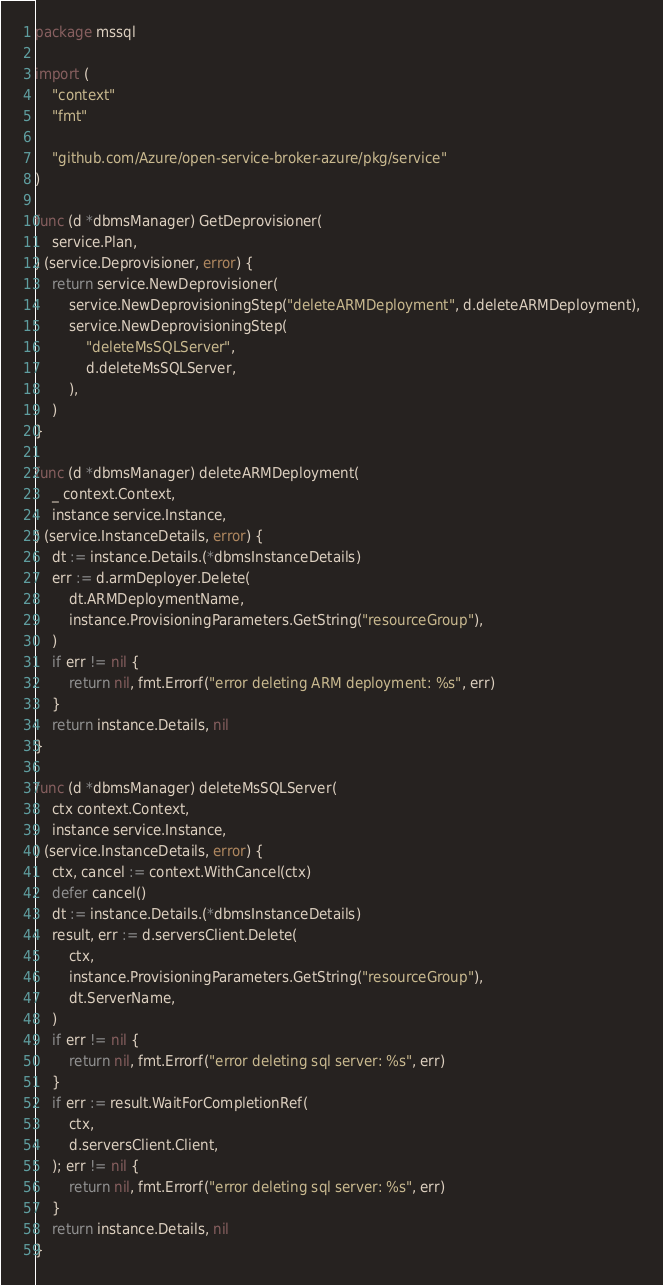Convert code to text. <code><loc_0><loc_0><loc_500><loc_500><_Go_>package mssql

import (
	"context"
	"fmt"

	"github.com/Azure/open-service-broker-azure/pkg/service"
)

func (d *dbmsManager) GetDeprovisioner(
	service.Plan,
) (service.Deprovisioner, error) {
	return service.NewDeprovisioner(
		service.NewDeprovisioningStep("deleteARMDeployment", d.deleteARMDeployment),
		service.NewDeprovisioningStep(
			"deleteMsSQLServer",
			d.deleteMsSQLServer,
		),
	)
}

func (d *dbmsManager) deleteARMDeployment(
	_ context.Context,
	instance service.Instance,
) (service.InstanceDetails, error) {
	dt := instance.Details.(*dbmsInstanceDetails)
	err := d.armDeployer.Delete(
		dt.ARMDeploymentName,
		instance.ProvisioningParameters.GetString("resourceGroup"),
	)
	if err != nil {
		return nil, fmt.Errorf("error deleting ARM deployment: %s", err)
	}
	return instance.Details, nil
}

func (d *dbmsManager) deleteMsSQLServer(
	ctx context.Context,
	instance service.Instance,
) (service.InstanceDetails, error) {
	ctx, cancel := context.WithCancel(ctx)
	defer cancel()
	dt := instance.Details.(*dbmsInstanceDetails)
	result, err := d.serversClient.Delete(
		ctx,
		instance.ProvisioningParameters.GetString("resourceGroup"),
		dt.ServerName,
	)
	if err != nil {
		return nil, fmt.Errorf("error deleting sql server: %s", err)
	}
	if err := result.WaitForCompletionRef(
		ctx,
		d.serversClient.Client,
	); err != nil {
		return nil, fmt.Errorf("error deleting sql server: %s", err)
	}
	return instance.Details, nil
}
</code> 